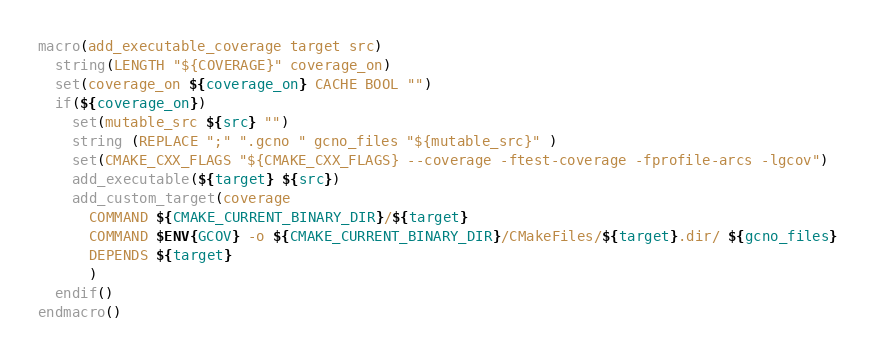<code> <loc_0><loc_0><loc_500><loc_500><_CMake_>macro(add_executable_coverage target src)
  string(LENGTH "${COVERAGE}" coverage_on)
  set(coverage_on ${coverage_on} CACHE BOOL "")
  if(${coverage_on})
    set(mutable_src ${src} "")
    string (REPLACE ";" ".gcno " gcno_files "${mutable_src}" )
    set(CMAKE_CXX_FLAGS "${CMAKE_CXX_FLAGS} --coverage -ftest-coverage -fprofile-arcs -lgcov")
    add_executable(${target} ${src})
    add_custom_target(coverage
      COMMAND ${CMAKE_CURRENT_BINARY_DIR}/${target}
      COMMAND $ENV{GCOV} -o ${CMAKE_CURRENT_BINARY_DIR}/CMakeFiles/${target}.dir/ ${gcno_files}
      DEPENDS ${target}
      )
  endif()
endmacro()
</code> 